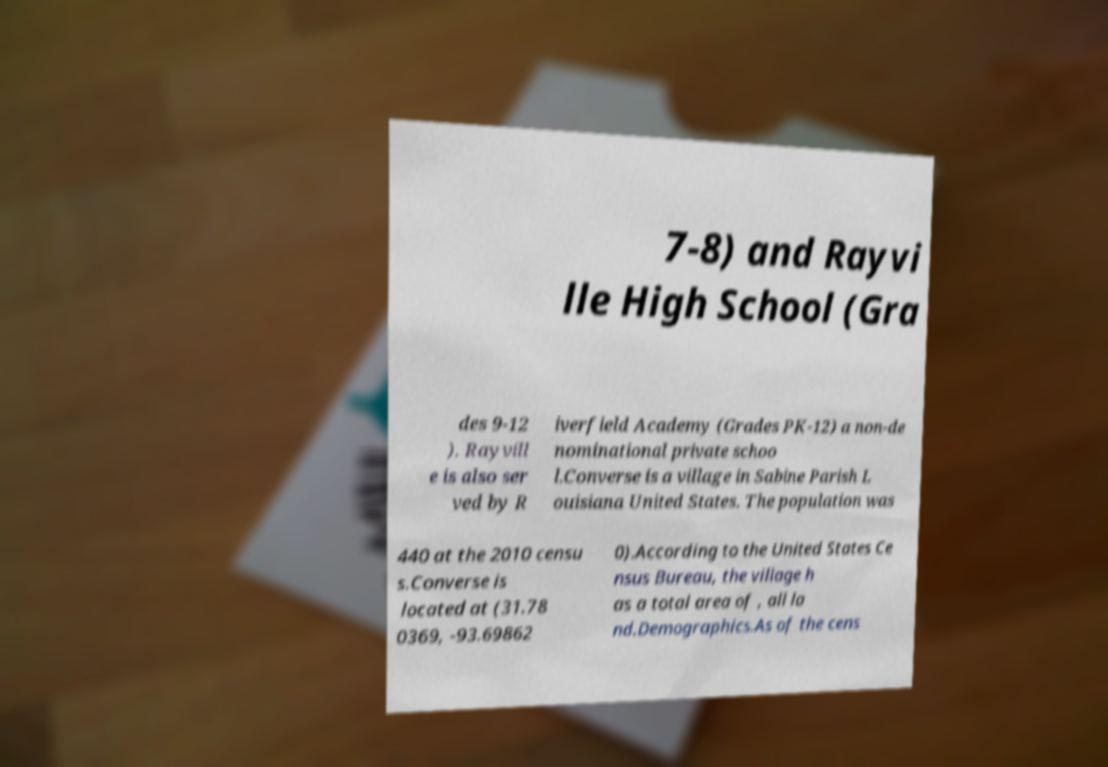I need the written content from this picture converted into text. Can you do that? 7-8) and Rayvi lle High School (Gra des 9-12 ). Rayvill e is also ser ved by R iverfield Academy (Grades PK-12) a non-de nominational private schoo l.Converse is a village in Sabine Parish L ouisiana United States. The population was 440 at the 2010 censu s.Converse is located at (31.78 0369, -93.69862 0).According to the United States Ce nsus Bureau, the village h as a total area of , all la nd.Demographics.As of the cens 